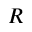<formula> <loc_0><loc_0><loc_500><loc_500>R</formula> 